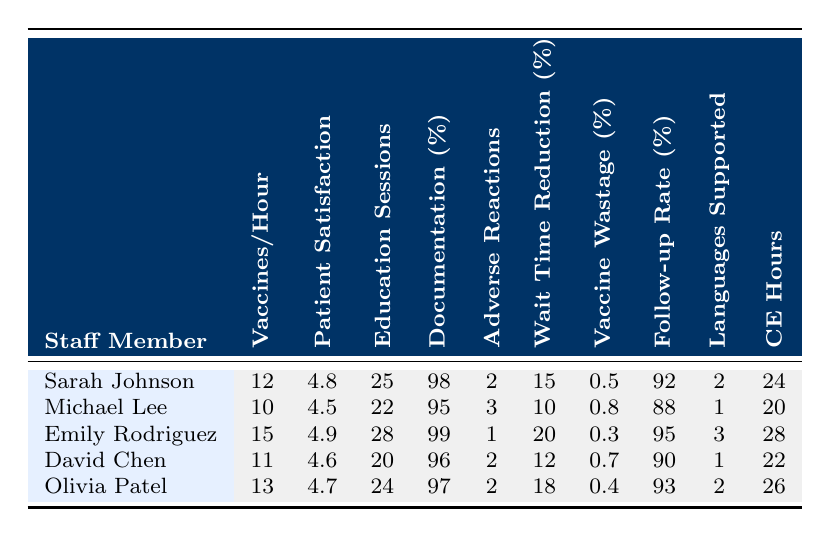What is the highest number of vaccines administered per hour? The highest number in the "Vaccines/Hour" column is 15, which corresponds to Emily Rodriguez.
Answer: 15 What is the patient satisfaction score for Michael Lee? Referring to the "Patient Satisfaction" column, Michael Lee has a score of 4.5.
Answer: 4.5 How many education sessions did Sarah Johnson complete? The "Education Sessions" column shows Sarah Johnson completed 25 sessions.
Answer: 25 What is the average documentation accuracy percentage for all staff members? The accuracy percentages are 98, 95, 99, 96, and 97. The sum is 485, and dividing by 5 gives an average of 97.
Answer: 97 Who has the lowest patient satisfaction score? Looking through the "Patient Satisfaction" column, Michael Lee has the lowest score at 4.5.
Answer: Michael Lee What is the total number of education sessions completed by all staff? Summing the education sessions (25 + 22 + 28 + 20 + 24) equals 119.
Answer: 119 Which staff member reported the least adverse reactions? Checking the "Adverse Reactions" column, Emily Rodriguez reported only 1 adverse reaction.
Answer: Emily Rodriguez Is Olivia Patel's waiting time reduction percentage higher than Michael Lee's? Checking the "Wait Time Reduction" column, Olivia has 18% while Michael has 10%, thus true.
Answer: Yes What is the difference in vaccine wastage percentage between Emily Rodriguez and Michael Lee? Emily's wastage is 0.3% and Michael's is 0.8%, the difference is 0.8 - 0.3 = 0.5%.
Answer: 0.5% Which staff members have more than 95% documentation accuracy? Checking the "Documentation (%)" column, Sarah Johnson, Emily Rodriguez, and Olivia Patel have accuracy greater than 95%.
Answer: Sarah Johnson, Emily Rodriguez, Olivia Patel What is the median number of education sessions completed among all staff? The education sessions are 25, 22, 28, 20, and 24. When ordered (20, 22, 24, 25, 28), the middle value is 24.
Answer: 24 How many languages does Emily Rodriguez support? Referring to the "Languages Supported" column, Emily Rodriguez supports 3 languages.
Answer: 3 Do all staff members meet or exceed a patient satisfaction score of 4.5? Checking the "Patient Satisfaction" scores, all scores either meet or exceed 4.5, thus true.
Answer: Yes What percentage of vaccines administered by David Chen were reported as wasted? David Chen's wastage percentage is noted as 0.7% in the "Vaccine Wastage (%)" column.
Answer: 0.7% What is the total follow-up completion rate across all staff? The follow-up rates are 92, 88, 95, 90, and 93. The total is 458, giving an average of 91.6.
Answer: 458 